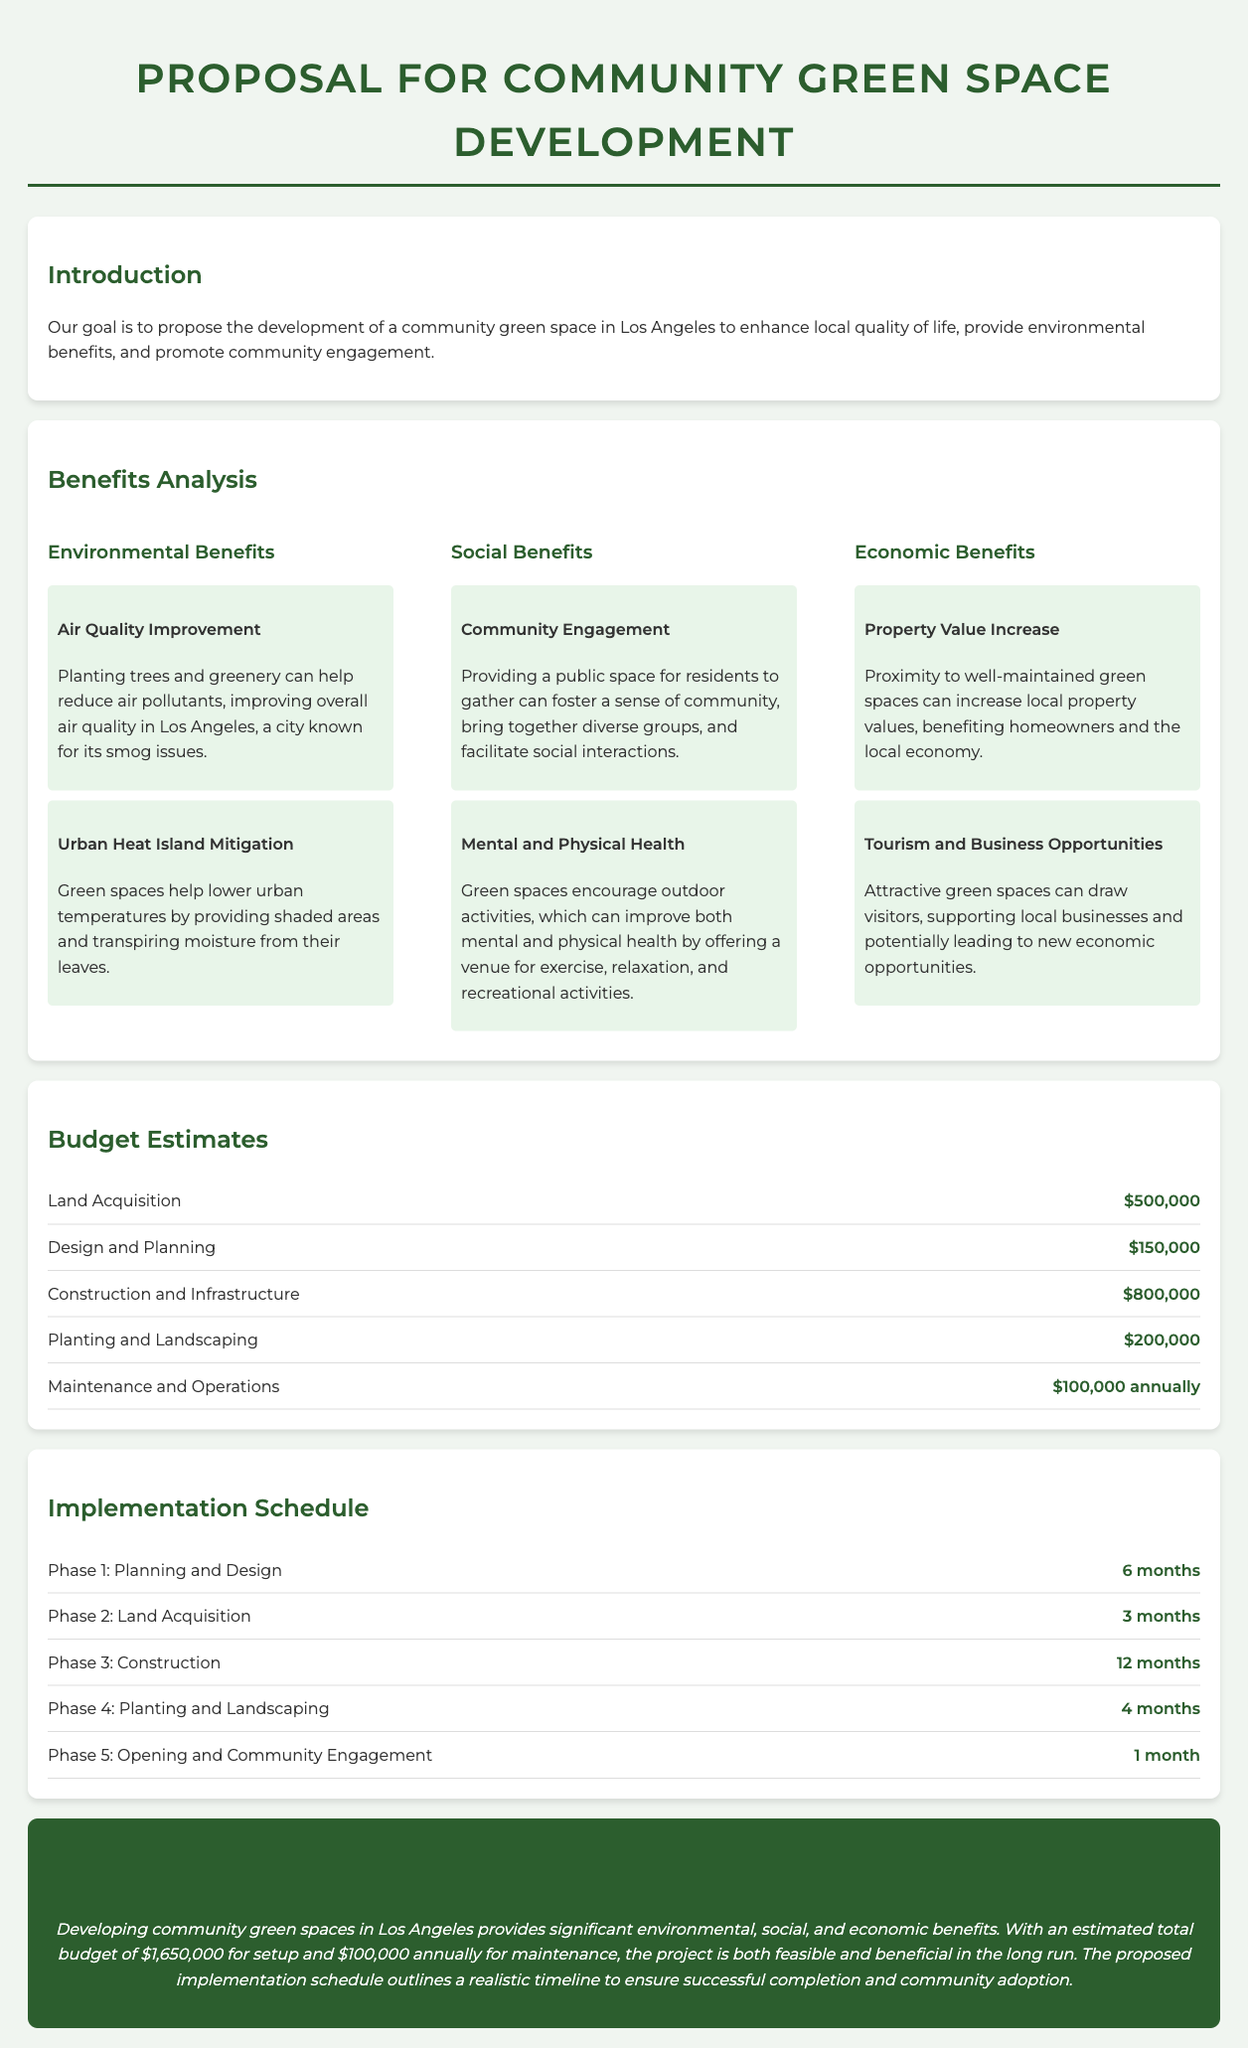What is the total budget for setup? The total budget is mentioned in the conclusion as the estimated amount needed for setup, which is $1,650,000.
Answer: $1,650,000 What are the social benefits mentioned? The document lists two key social benefits under the benefits analysis section: Community Engagement and Mental and Physical Health.
Answer: Community Engagement, Mental and Physical Health How long is Phase 3: Construction scheduled to last? The implementation schedule indicates that Phase 3: Construction will last for 12 months.
Answer: 12 months How much is allocated for Land Acquisition? The budget estimates specify the cost of Land Acquisition, which is $500,000.
Answer: $500,000 What is one way green spaces contribute to property values? The document states that proximity to well-maintained green spaces can increase local property values, benefiting homeowners and the local economy.
Answer: Increase local property values What is the maintenance cost mentioned annually? The budget section includes a line for maintenance and operations, stating it will cost $100,000 annually.
Answer: $100,000 annually What is the total timeline for the implementation schedule? The timeline for the overall implementation can be calculated by adding the durations of all phases: 6 + 3 + 12 + 4 + 1 = 26 months.
Answer: 26 months What environmental benefit helps with urban heat island mitigation? One of the environmental benefits listed is Urban Heat Island Mitigation, which states that green spaces help lower urban temperatures.
Answer: Urban Heat Island Mitigation What is the focus of the proposal? The introduction states that the proposal's goal is to enhance local quality of life, provide environmental benefits, and promote community engagement.
Answer: Enhance local quality of life 